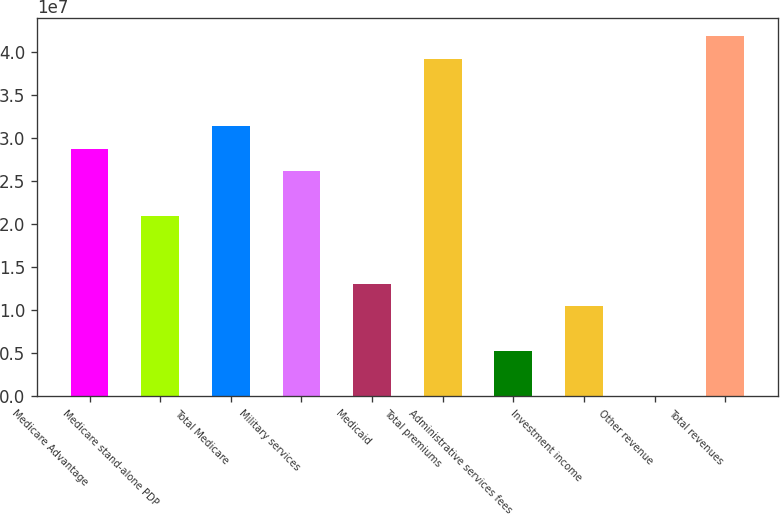<chart> <loc_0><loc_0><loc_500><loc_500><bar_chart><fcel>Medicare Advantage<fcel>Medicare stand-alone PDP<fcel>Total Medicare<fcel>Military services<fcel>Medicaid<fcel>Total premiums<fcel>Administrative services fees<fcel>Investment income<fcel>Other revenue<fcel>Total revenues<nl><fcel>2.87388e+07<fcel>2.09026e+07<fcel>3.13509e+07<fcel>2.61267e+07<fcel>1.30663e+07<fcel>3.91871e+07<fcel>5.2301e+06<fcel>1.04543e+07<fcel>5946<fcel>4.17992e+07<nl></chart> 